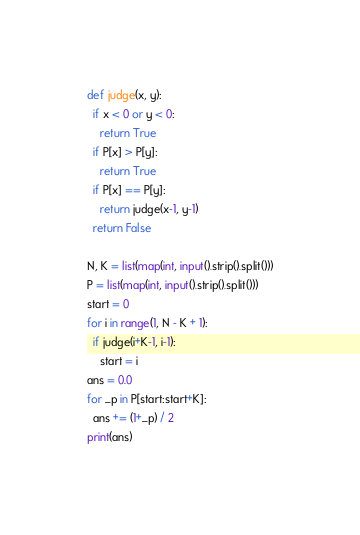<code> <loc_0><loc_0><loc_500><loc_500><_Python_>def judge(x, y):
  if x < 0 or y < 0:
    return True
  if P[x] > P[y]:
    return True
  if P[x] == P[y]:
    return judge(x-1, y-1)
  return False

N, K = list(map(int, input().strip().split()))
P = list(map(int, input().strip().split()))
start = 0
for i in range(1, N - K + 1):
  if judge(i+K-1, i-1):
    start = i
ans = 0.0
for _p in P[start:start+K]:
  ans += (1+_p) / 2
print(ans)</code> 